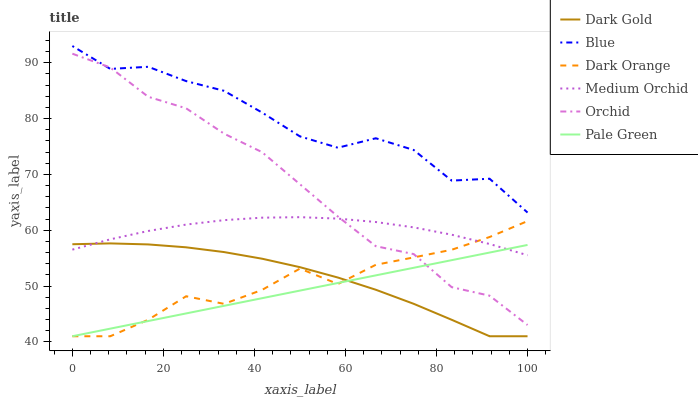Does Pale Green have the minimum area under the curve?
Answer yes or no. Yes. Does Blue have the maximum area under the curve?
Answer yes or no. Yes. Does Dark Orange have the minimum area under the curve?
Answer yes or no. No. Does Dark Orange have the maximum area under the curve?
Answer yes or no. No. Is Pale Green the smoothest?
Answer yes or no. Yes. Is Blue the roughest?
Answer yes or no. Yes. Is Dark Orange the smoothest?
Answer yes or no. No. Is Dark Orange the roughest?
Answer yes or no. No. Does Dark Orange have the lowest value?
Answer yes or no. Yes. Does Medium Orchid have the lowest value?
Answer yes or no. No. Does Blue have the highest value?
Answer yes or no. Yes. Does Dark Orange have the highest value?
Answer yes or no. No. Is Pale Green less than Blue?
Answer yes or no. Yes. Is Orchid greater than Dark Gold?
Answer yes or no. Yes. Does Blue intersect Orchid?
Answer yes or no. Yes. Is Blue less than Orchid?
Answer yes or no. No. Is Blue greater than Orchid?
Answer yes or no. No. Does Pale Green intersect Blue?
Answer yes or no. No. 